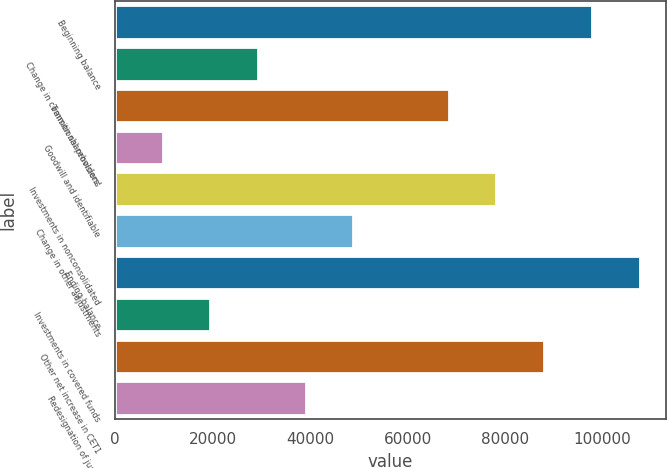<chart> <loc_0><loc_0><loc_500><loc_500><bar_chart><fcel>Beginning balance<fcel>Change in common shareholders'<fcel>Transitional provisions<fcel>Goodwill and identifiable<fcel>Investments in nonconsolidated<fcel>Change in other adjustments<fcel>Ending balance<fcel>Investments in covered funds<fcel>Other net increase in CET1<fcel>Redesignation of junior<nl><fcel>97792<fcel>29339.7<fcel>68455.3<fcel>9781.9<fcel>78234.2<fcel>48897.5<fcel>107571<fcel>19560.8<fcel>88013.1<fcel>39118.6<nl></chart> 